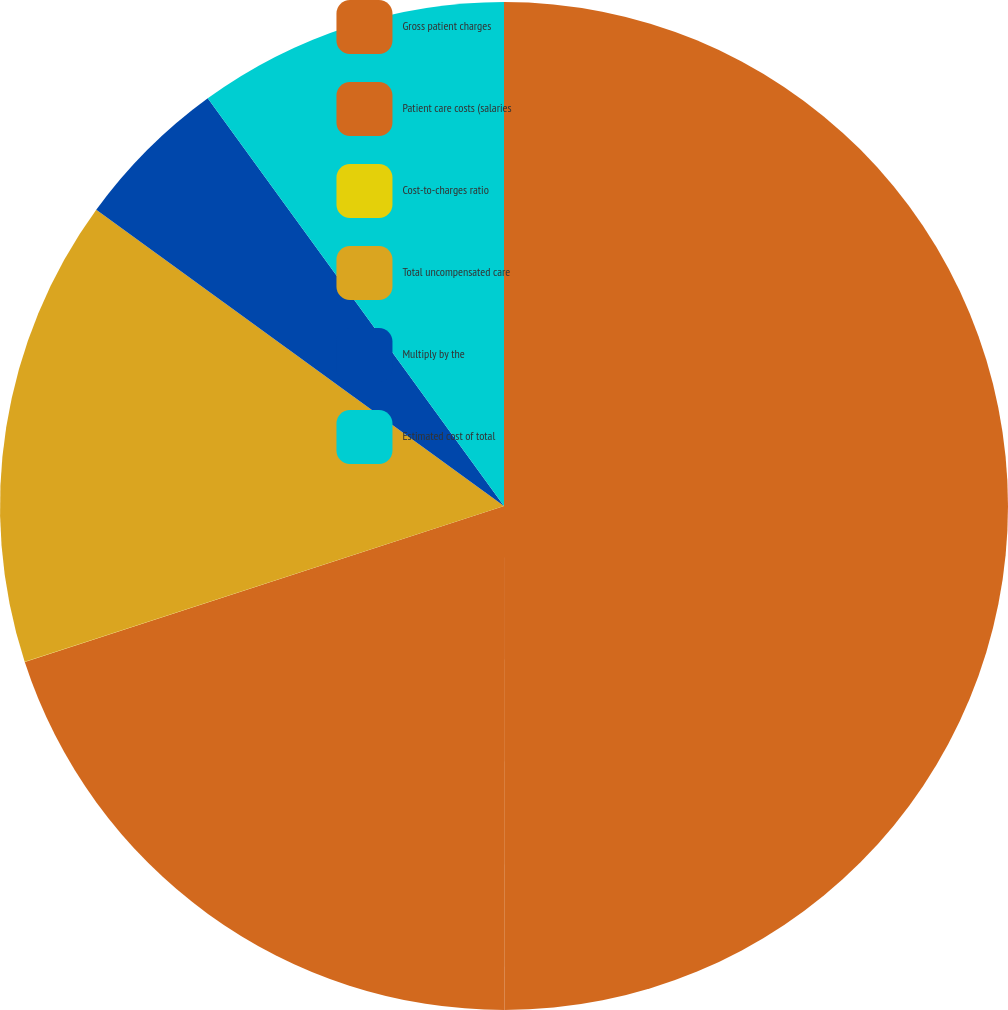Convert chart to OTSL. <chart><loc_0><loc_0><loc_500><loc_500><pie_chart><fcel>Gross patient charges<fcel>Patient care costs (salaries<fcel>Cost-to-charges ratio<fcel>Total uncompensated care<fcel>Multiply by the<fcel>Estimated cost of total<nl><fcel>49.99%<fcel>20.0%<fcel>0.01%<fcel>15.0%<fcel>5.0%<fcel>10.0%<nl></chart> 